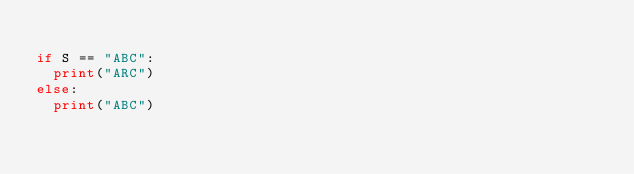<code> <loc_0><loc_0><loc_500><loc_500><_Python_>
if S == "ABC":
  print("ARC")
else:
  print("ABC")</code> 